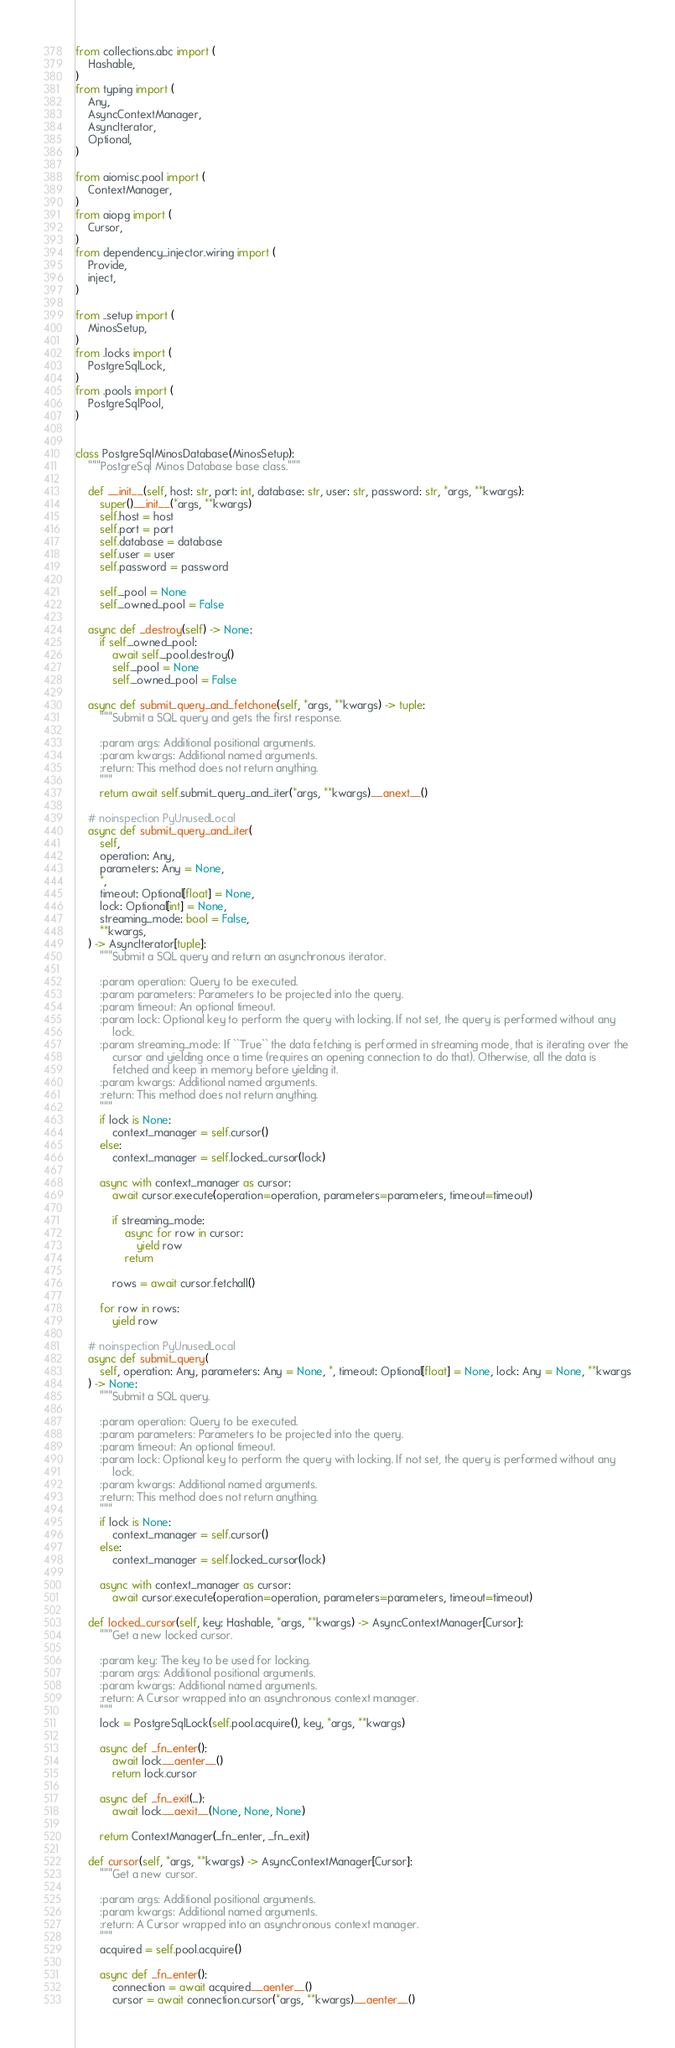<code> <loc_0><loc_0><loc_500><loc_500><_Python_>from collections.abc import (
    Hashable,
)
from typing import (
    Any,
    AsyncContextManager,
    AsyncIterator,
    Optional,
)

from aiomisc.pool import (
    ContextManager,
)
from aiopg import (
    Cursor,
)
from dependency_injector.wiring import (
    Provide,
    inject,
)

from ..setup import (
    MinosSetup,
)
from .locks import (
    PostgreSqlLock,
)
from .pools import (
    PostgreSqlPool,
)


class PostgreSqlMinosDatabase(MinosSetup):
    """PostgreSql Minos Database base class."""

    def __init__(self, host: str, port: int, database: str, user: str, password: str, *args, **kwargs):
        super().__init__(*args, **kwargs)
        self.host = host
        self.port = port
        self.database = database
        self.user = user
        self.password = password

        self._pool = None
        self._owned_pool = False

    async def _destroy(self) -> None:
        if self._owned_pool:
            await self._pool.destroy()
            self._pool = None
            self._owned_pool = False

    async def submit_query_and_fetchone(self, *args, **kwargs) -> tuple:
        """Submit a SQL query and gets the first response.

        :param args: Additional positional arguments.
        :param kwargs: Additional named arguments.
        :return: This method does not return anything.
        """
        return await self.submit_query_and_iter(*args, **kwargs).__anext__()

    # noinspection PyUnusedLocal
    async def submit_query_and_iter(
        self,
        operation: Any,
        parameters: Any = None,
        *,
        timeout: Optional[float] = None,
        lock: Optional[int] = None,
        streaming_mode: bool = False,
        **kwargs,
    ) -> AsyncIterator[tuple]:
        """Submit a SQL query and return an asynchronous iterator.

        :param operation: Query to be executed.
        :param parameters: Parameters to be projected into the query.
        :param timeout: An optional timeout.
        :param lock: Optional key to perform the query with locking. If not set, the query is performed without any
            lock.
        :param streaming_mode: If ``True`` the data fetching is performed in streaming mode, that is iterating over the
            cursor and yielding once a time (requires an opening connection to do that). Otherwise, all the data is
            fetched and keep in memory before yielding it.
        :param kwargs: Additional named arguments.
        :return: This method does not return anything.
        """
        if lock is None:
            context_manager = self.cursor()
        else:
            context_manager = self.locked_cursor(lock)

        async with context_manager as cursor:
            await cursor.execute(operation=operation, parameters=parameters, timeout=timeout)

            if streaming_mode:
                async for row in cursor:
                    yield row
                return

            rows = await cursor.fetchall()

        for row in rows:
            yield row

    # noinspection PyUnusedLocal
    async def submit_query(
        self, operation: Any, parameters: Any = None, *, timeout: Optional[float] = None, lock: Any = None, **kwargs
    ) -> None:
        """Submit a SQL query.

        :param operation: Query to be executed.
        :param parameters: Parameters to be projected into the query.
        :param timeout: An optional timeout.
        :param lock: Optional key to perform the query with locking. If not set, the query is performed without any
            lock.
        :param kwargs: Additional named arguments.
        :return: This method does not return anything.
        """
        if lock is None:
            context_manager = self.cursor()
        else:
            context_manager = self.locked_cursor(lock)

        async with context_manager as cursor:
            await cursor.execute(operation=operation, parameters=parameters, timeout=timeout)

    def locked_cursor(self, key: Hashable, *args, **kwargs) -> AsyncContextManager[Cursor]:
        """Get a new locked cursor.

        :param key: The key to be used for locking.
        :param args: Additional positional arguments.
        :param kwargs: Additional named arguments.
        :return: A Cursor wrapped into an asynchronous context manager.
        """
        lock = PostgreSqlLock(self.pool.acquire(), key, *args, **kwargs)

        async def _fn_enter():
            await lock.__aenter__()
            return lock.cursor

        async def _fn_exit(_):
            await lock.__aexit__(None, None, None)

        return ContextManager(_fn_enter, _fn_exit)

    def cursor(self, *args, **kwargs) -> AsyncContextManager[Cursor]:
        """Get a new cursor.

        :param args: Additional positional arguments.
        :param kwargs: Additional named arguments.
        :return: A Cursor wrapped into an asynchronous context manager.
        """
        acquired = self.pool.acquire()

        async def _fn_enter():
            connection = await acquired.__aenter__()
            cursor = await connection.cursor(*args, **kwargs).__aenter__()</code> 